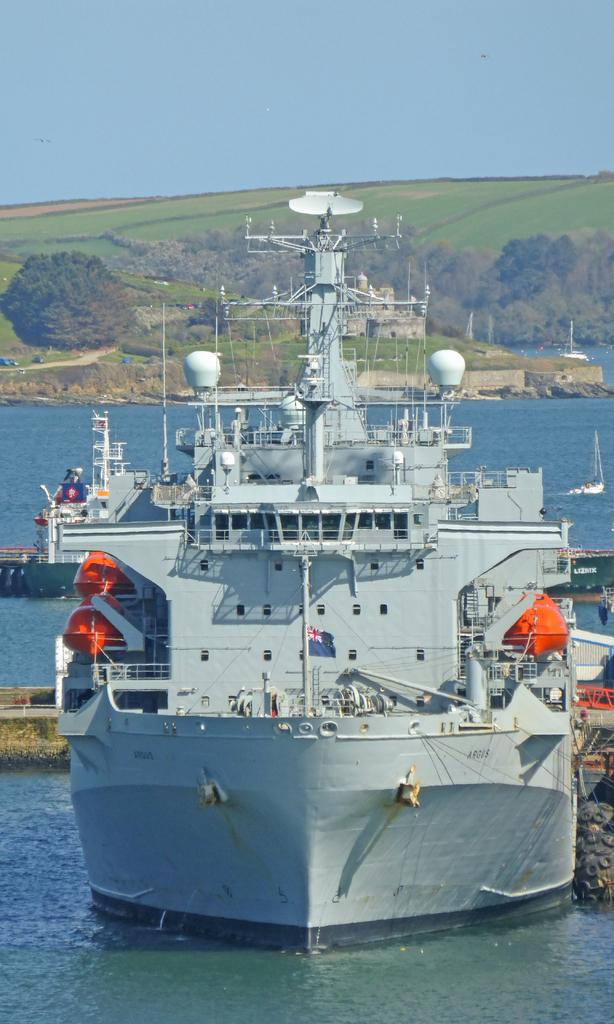What is the main subject of the image? There is a ship in the image. What type of natural environment is visible in the image? There are trees and water visible in the image. What else can be seen in the sky in the image? The sky is visible in the image. What type of food is being served under the veil in the image? There is no food or veil present in the image; it features a ship, trees, water, and the sky. 